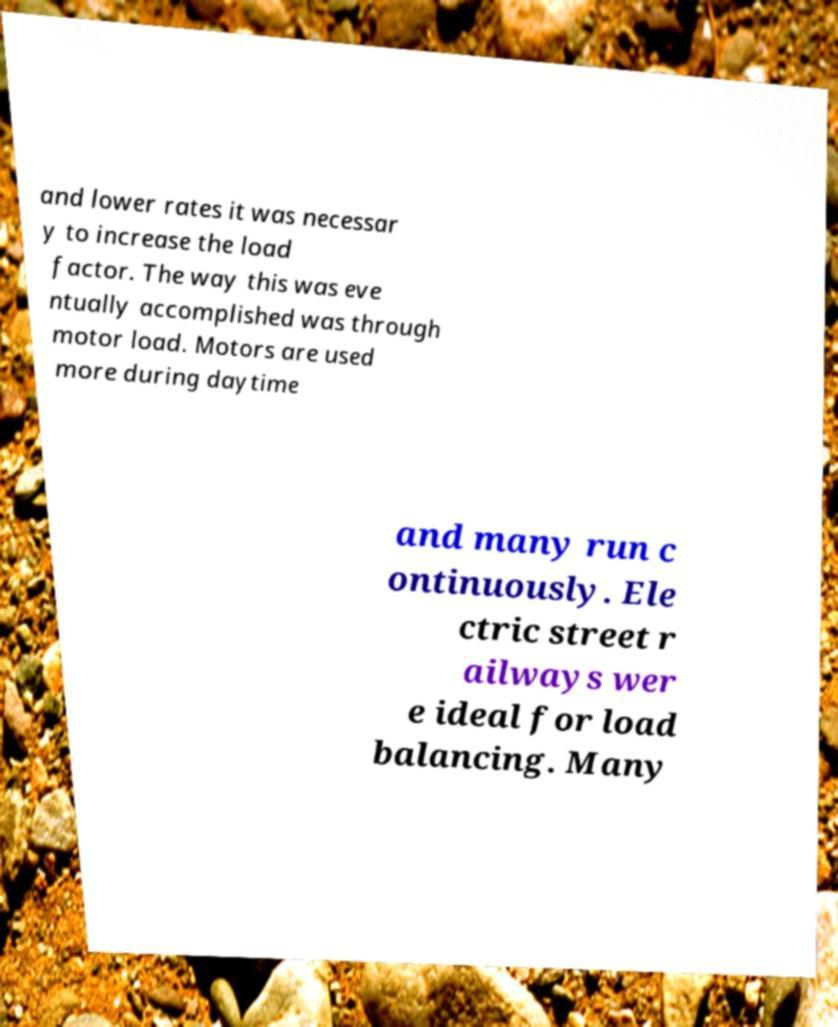Can you read and provide the text displayed in the image?This photo seems to have some interesting text. Can you extract and type it out for me? and lower rates it was necessar y to increase the load factor. The way this was eve ntually accomplished was through motor load. Motors are used more during daytime and many run c ontinuously. Ele ctric street r ailways wer e ideal for load balancing. Many 